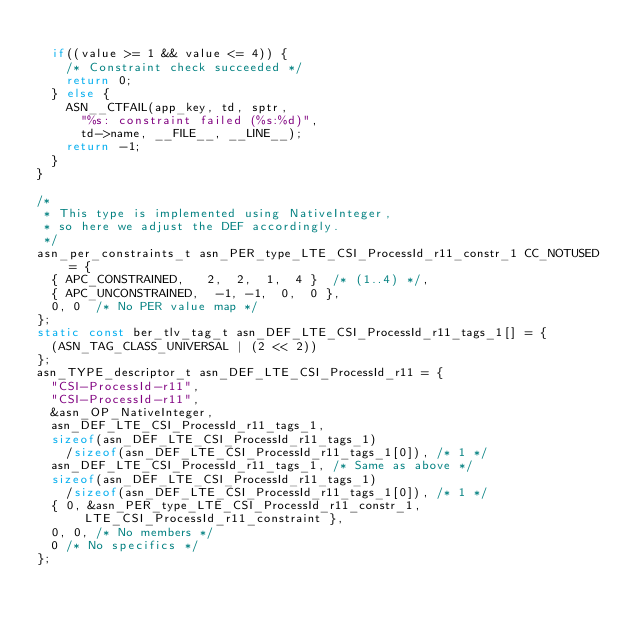<code> <loc_0><loc_0><loc_500><loc_500><_C_>	
	if((value >= 1 && value <= 4)) {
		/* Constraint check succeeded */
		return 0;
	} else {
		ASN__CTFAIL(app_key, td, sptr,
			"%s: constraint failed (%s:%d)",
			td->name, __FILE__, __LINE__);
		return -1;
	}
}

/*
 * This type is implemented using NativeInteger,
 * so here we adjust the DEF accordingly.
 */
asn_per_constraints_t asn_PER_type_LTE_CSI_ProcessId_r11_constr_1 CC_NOTUSED = {
	{ APC_CONSTRAINED,	 2,  2,  1,  4 }	/* (1..4) */,
	{ APC_UNCONSTRAINED,	-1, -1,  0,  0 },
	0, 0	/* No PER value map */
};
static const ber_tlv_tag_t asn_DEF_LTE_CSI_ProcessId_r11_tags_1[] = {
	(ASN_TAG_CLASS_UNIVERSAL | (2 << 2))
};
asn_TYPE_descriptor_t asn_DEF_LTE_CSI_ProcessId_r11 = {
	"CSI-ProcessId-r11",
	"CSI-ProcessId-r11",
	&asn_OP_NativeInteger,
	asn_DEF_LTE_CSI_ProcessId_r11_tags_1,
	sizeof(asn_DEF_LTE_CSI_ProcessId_r11_tags_1)
		/sizeof(asn_DEF_LTE_CSI_ProcessId_r11_tags_1[0]), /* 1 */
	asn_DEF_LTE_CSI_ProcessId_r11_tags_1,	/* Same as above */
	sizeof(asn_DEF_LTE_CSI_ProcessId_r11_tags_1)
		/sizeof(asn_DEF_LTE_CSI_ProcessId_r11_tags_1[0]), /* 1 */
	{ 0, &asn_PER_type_LTE_CSI_ProcessId_r11_constr_1, LTE_CSI_ProcessId_r11_constraint },
	0, 0,	/* No members */
	0	/* No specifics */
};

</code> 